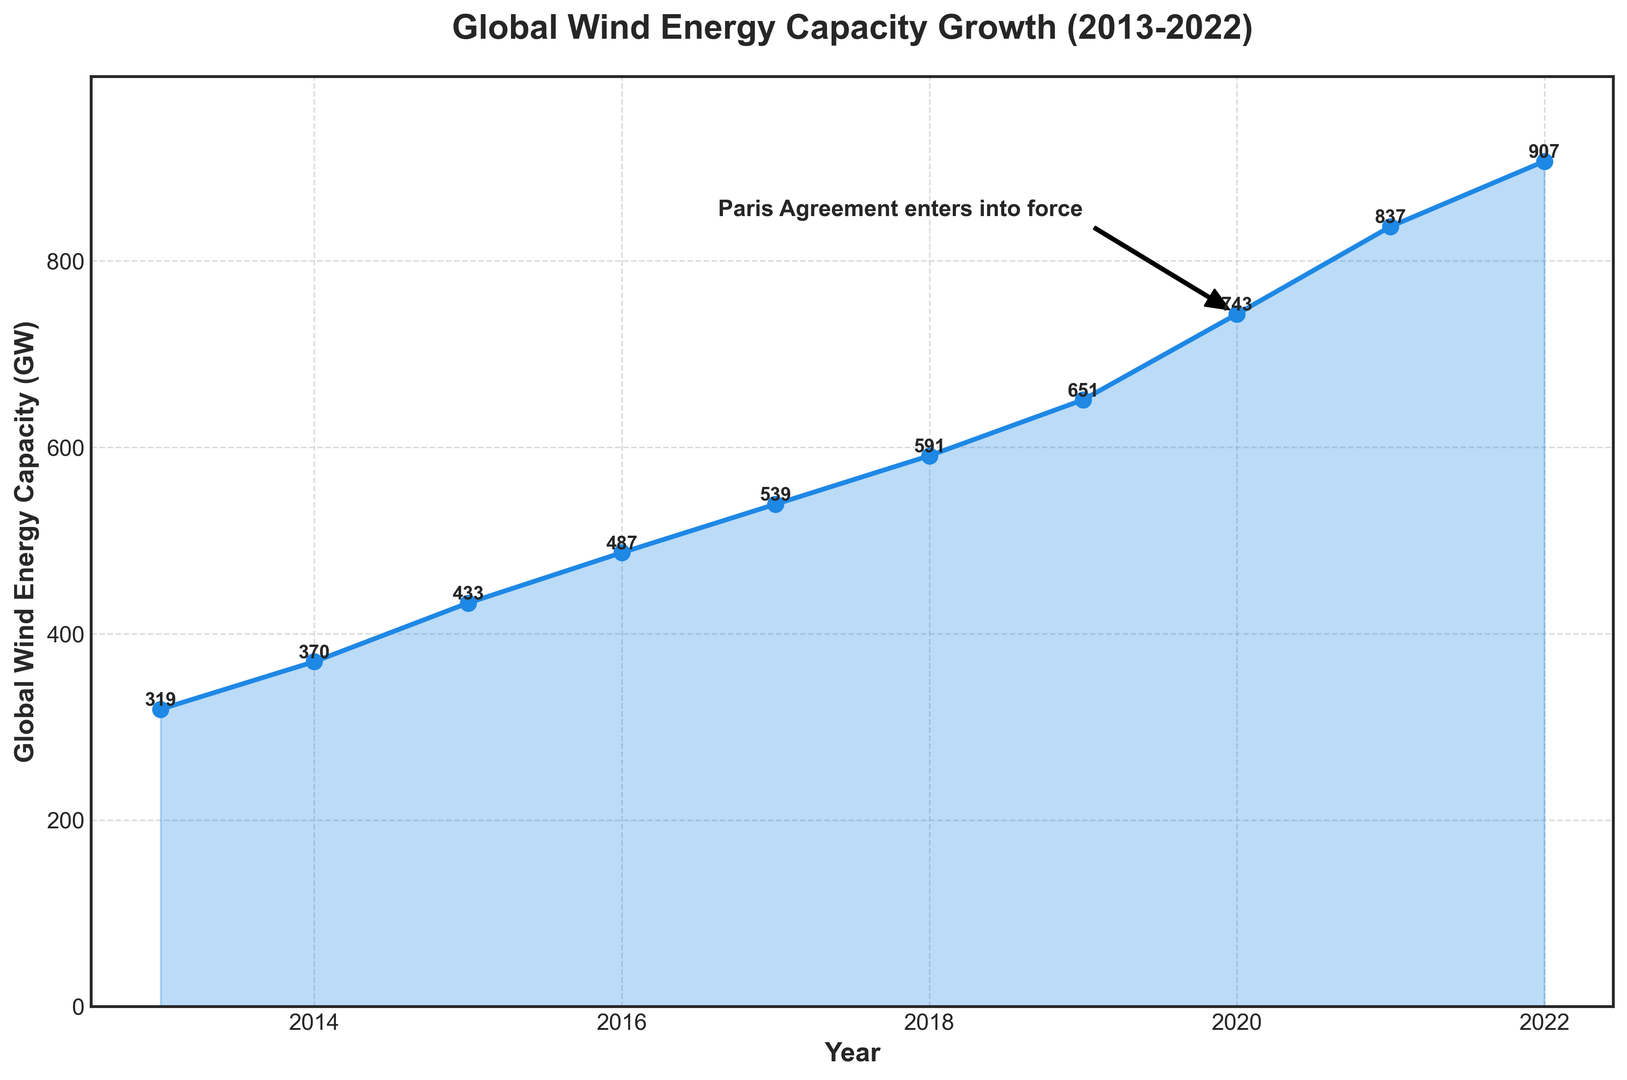When did the Paris Agreement enter into force according to the figure? The annotation on the chart specifies "Paris Agreement enters into force" next to the year 2020.
Answer: 2020 What was the global wind energy capacity in 2016? The y-axis value corresponding to the year 2016 is approximately 487 GW.
Answer: 487 GW Which year saw the highest increase in global wind energy capacity? By comparing consecutive years, the largest increase is from 2020 to 2021, where capacity increased from 743 GW to 837 GW. This is an increase of 94 GW.
Answer: 2020 to 2021 Describe the growth trend of global wind energy capacity from 2013 to 2022. From 2013 to 2022, the global wind energy capacity shows a consistent upward trend with significant growth especially after 2019, indicated by a steeper slope in the plot.
Answer: Consistently upward What is the average annual increase in wind energy capacity between 2013 and 2022? First, find the total increase: 907 GW (2022) - 319 GW (2013) = 588 GW. Then divide by the number of intervals (2022-2013 = 9 years). So, the average annual increase is approximately 588/9 = 65.33 GW.
Answer: 65.33 GW How did the global wind energy capacity change from 2019 to 2022? The capacity increased from 651 GW in 2019 to 907 GW in 2022.
Answer: Increased by 256 GW By how much did the wind energy capacity grow from 2016 to 2020, and what might have influenced this growth? The wind energy capacity grew from 487 GW in 2016 to 743 GW in 2020, an increase of 256 GW. The Paris Agreement, which entered into force in 2020, may have influenced this growth by encouraging renewable energy investment.
Answer: Increased by 256 GW, possibly influenced by the Paris Agreement Which year can be associated with the most significant policy change according to the figure? The annotation "Paris Agreement enters into force" in 2020 indicates this year as associated with the most significant policy change.
Answer: 2020 What is the difference in wind energy capacity between the years 2014 and 2019? The capacity in 2019 is 651 GW and in 2014 is 370 GW. So, the difference is 651 - 370 = 281 GW.
Answer: 281 GW How does the wind energy capacity in 2022 compare to that in 2013? The capacity in 2022 is 907 GW and in 2013 is 319 GW. 907 GW is significantly higher than the 319 GW in 2013, showing a substantial increase over the decade.
Answer: Higher by 588 GW 